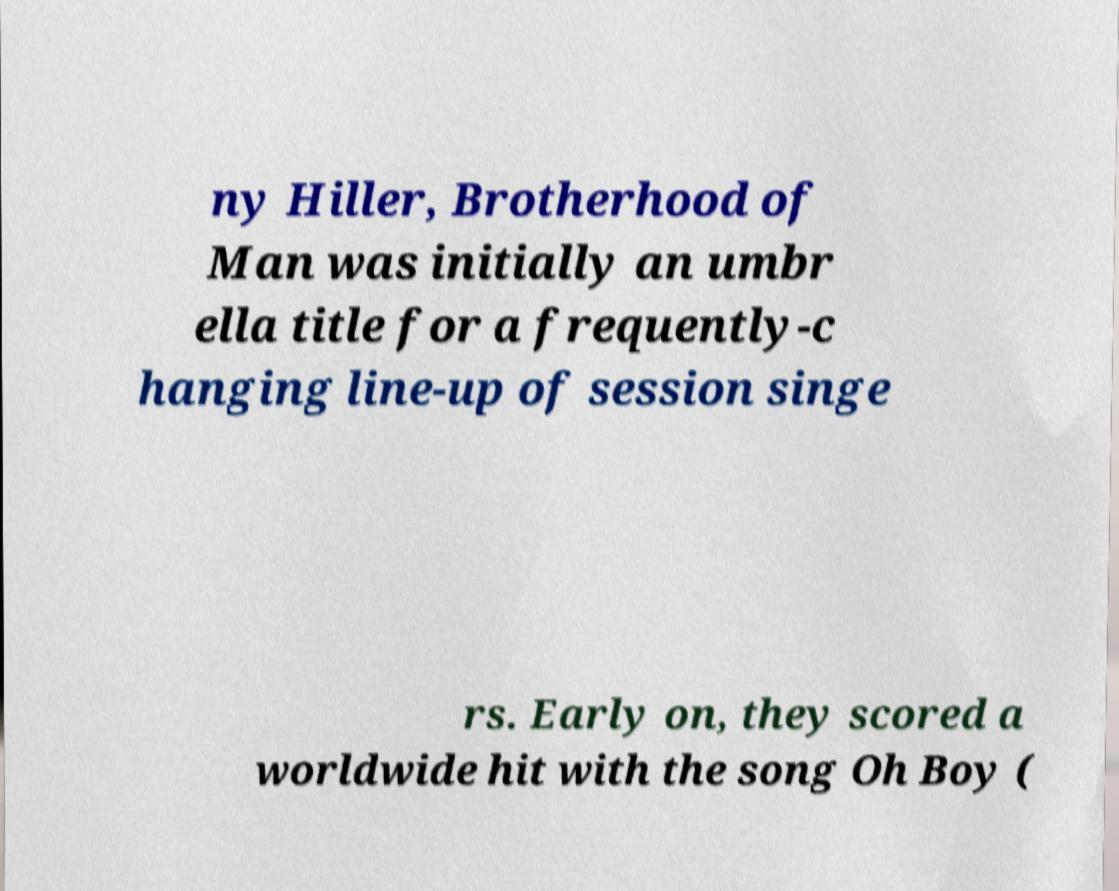Could you assist in decoding the text presented in this image and type it out clearly? ny Hiller, Brotherhood of Man was initially an umbr ella title for a frequently-c hanging line-up of session singe rs. Early on, they scored a worldwide hit with the song Oh Boy ( 